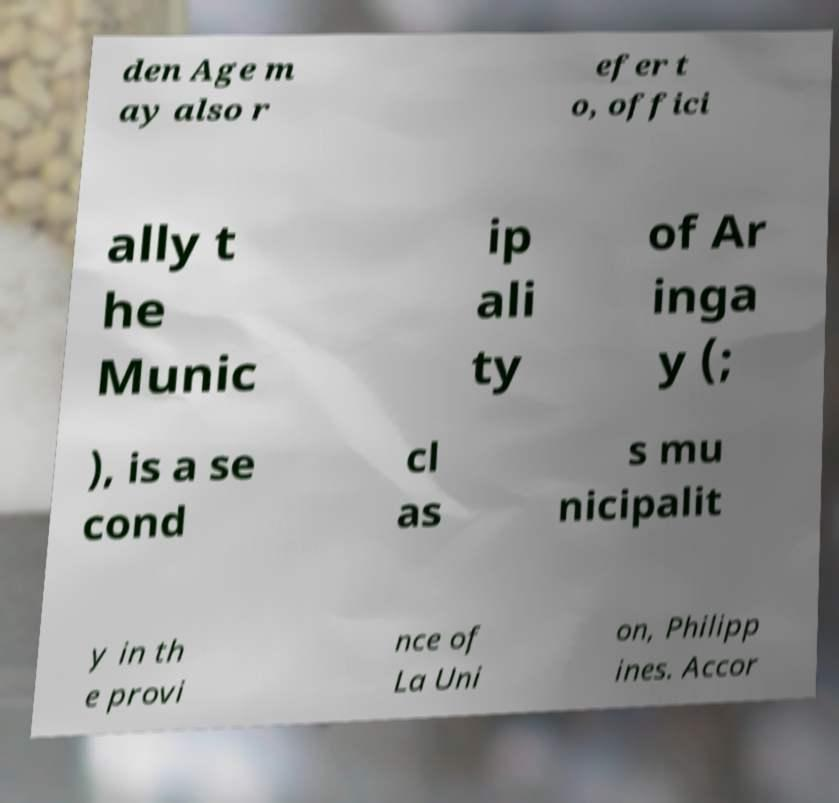Could you extract and type out the text from this image? den Age m ay also r efer t o, offici ally t he Munic ip ali ty of Ar inga y (; ), is a se cond cl as s mu nicipalit y in th e provi nce of La Uni on, Philipp ines. Accor 